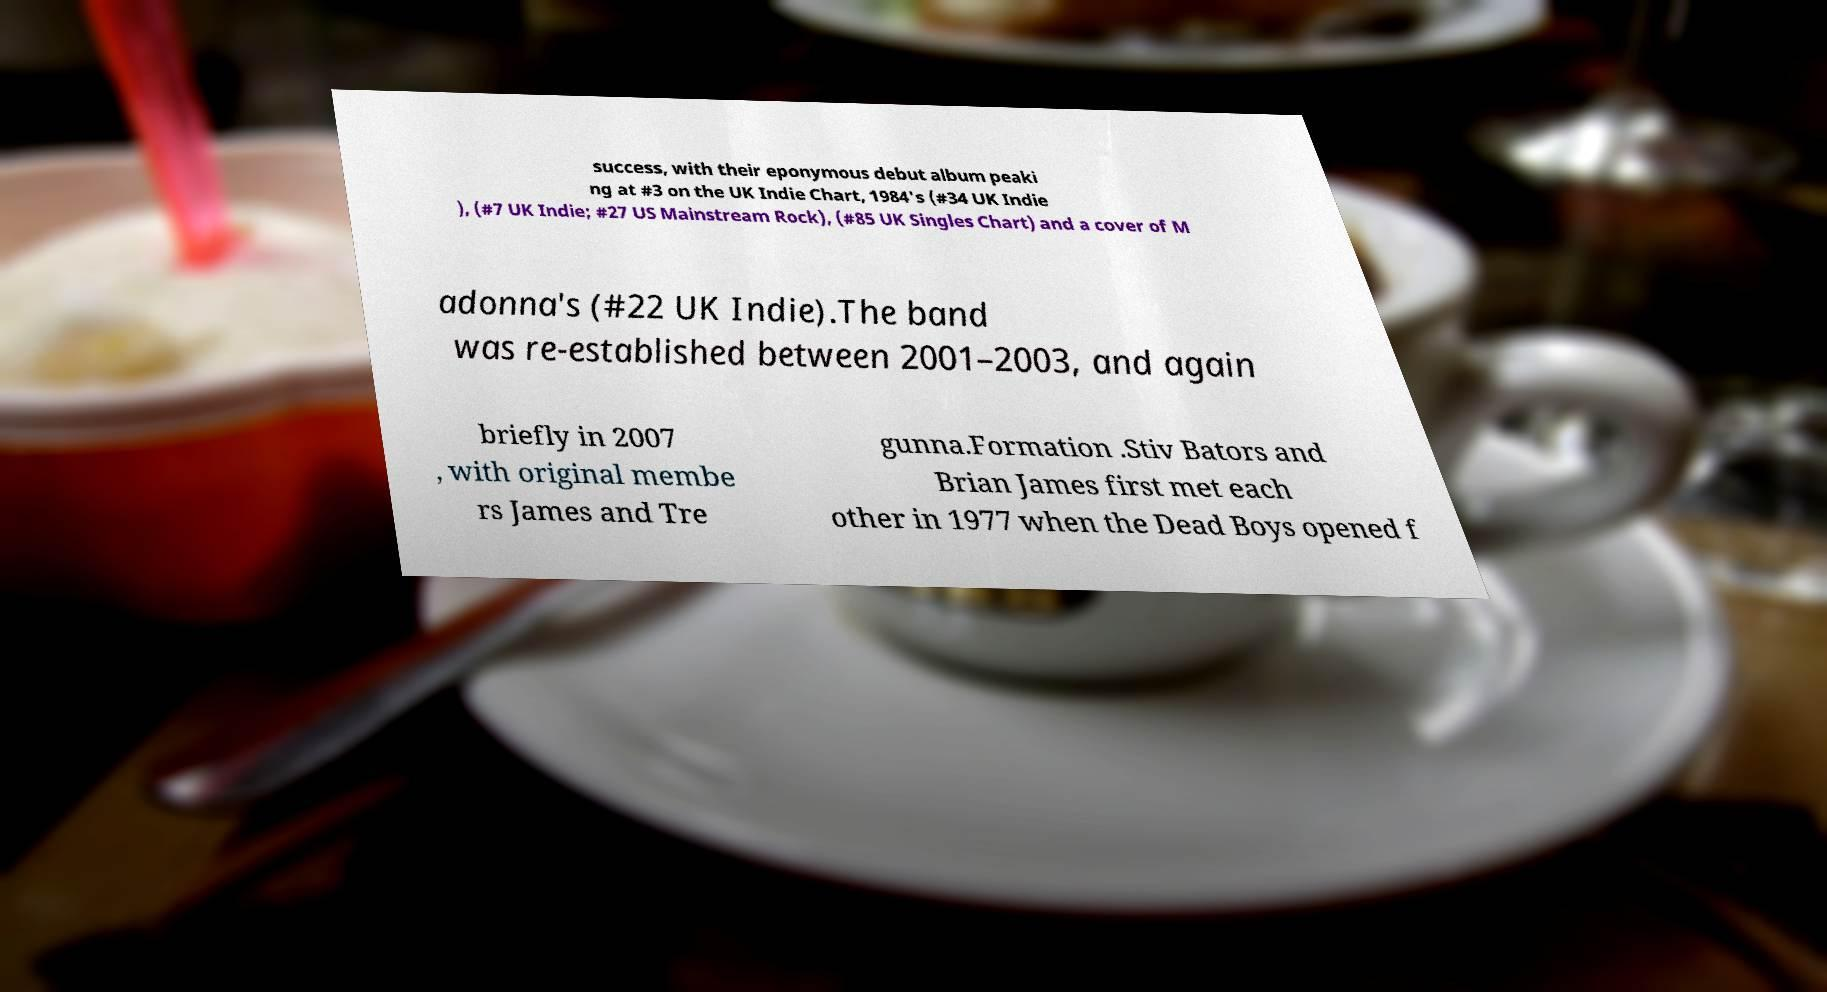What messages or text are displayed in this image? I need them in a readable, typed format. success, with their eponymous debut album peaki ng at #3 on the UK Indie Chart, 1984's (#34 UK Indie ), (#7 UK Indie; #27 US Mainstream Rock), (#85 UK Singles Chart) and a cover of M adonna's (#22 UK Indie).The band was re-established between 2001–2003, and again briefly in 2007 , with original membe rs James and Tre gunna.Formation .Stiv Bators and Brian James first met each other in 1977 when the Dead Boys opened f 